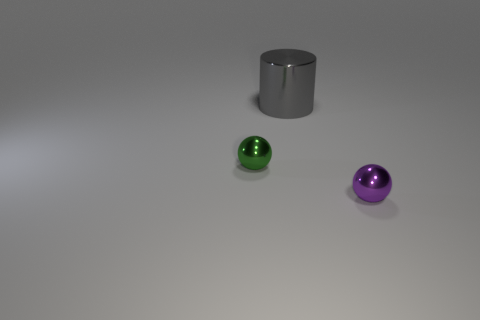What is the color of the object behind the sphere behind the small purple shiny ball?
Provide a short and direct response. Gray. Are there any tiny purple metal spheres?
Your answer should be very brief. Yes. What color is the shiny thing that is both behind the tiny purple thing and in front of the gray metallic cylinder?
Offer a very short reply. Green. There is a ball that is on the left side of the big gray cylinder; is it the same size as the ball right of the shiny cylinder?
Your answer should be very brief. Yes. What number of other objects are the same size as the purple thing?
Make the answer very short. 1. How many gray things are right of the thing that is in front of the small green metallic object?
Offer a terse response. 0. Is the number of small objects behind the small purple metal ball less than the number of green things?
Your answer should be very brief. No. What shape is the metal object that is in front of the small sphere that is behind the shiny object on the right side of the big metal cylinder?
Offer a very short reply. Sphere. Is the big metallic thing the same shape as the tiny green thing?
Your answer should be compact. No. How many other things are there of the same shape as the large metal object?
Your response must be concise. 0. 